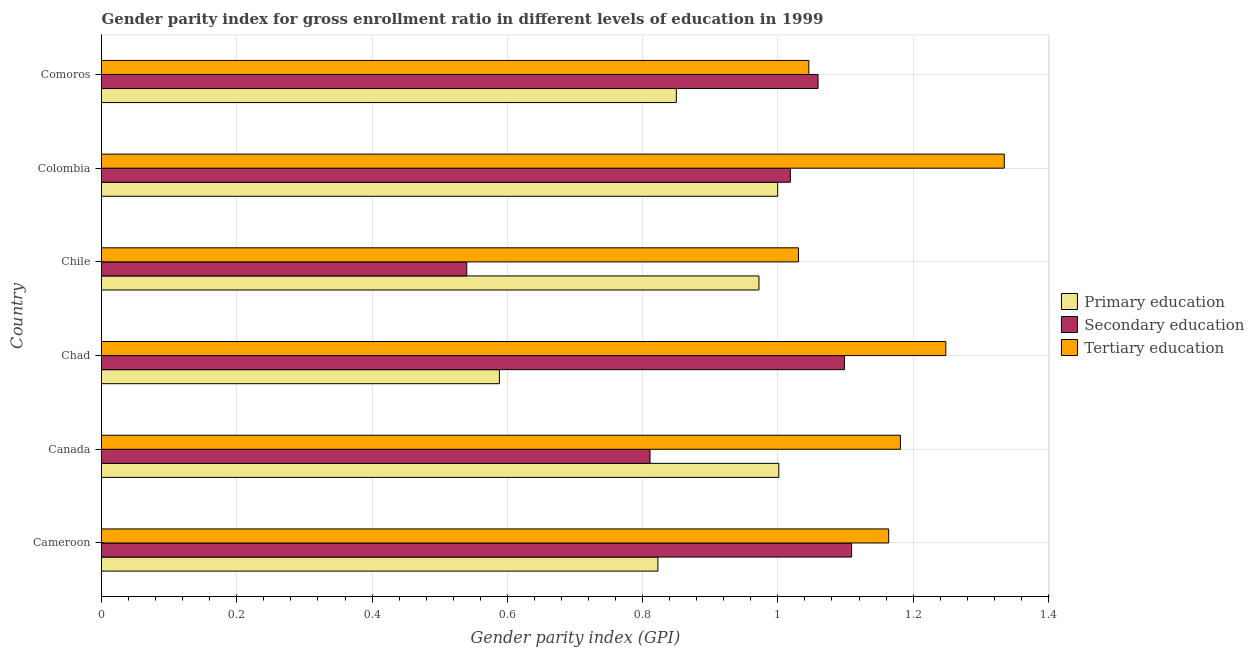How many different coloured bars are there?
Make the answer very short. 3. Are the number of bars per tick equal to the number of legend labels?
Offer a very short reply. Yes. What is the gender parity index in secondary education in Comoros?
Provide a succinct answer. 1.06. Across all countries, what is the maximum gender parity index in secondary education?
Your answer should be very brief. 1.11. Across all countries, what is the minimum gender parity index in tertiary education?
Provide a succinct answer. 1.03. In which country was the gender parity index in primary education minimum?
Your answer should be compact. Chad. What is the total gender parity index in primary education in the graph?
Your response must be concise. 5.23. What is the difference between the gender parity index in secondary education in Cameroon and that in Chile?
Your answer should be very brief. 0.57. What is the difference between the gender parity index in primary education in Colombia and the gender parity index in tertiary education in Chad?
Your answer should be very brief. -0.25. What is the average gender parity index in primary education per country?
Offer a terse response. 0.87. What is the difference between the gender parity index in primary education and gender parity index in tertiary education in Canada?
Offer a very short reply. -0.18. In how many countries, is the gender parity index in tertiary education greater than 0.16 ?
Ensure brevity in your answer.  6. What is the ratio of the gender parity index in secondary education in Cameroon to that in Chad?
Provide a short and direct response. 1.01. Is the difference between the gender parity index in secondary education in Canada and Chile greater than the difference between the gender parity index in primary education in Canada and Chile?
Provide a succinct answer. Yes. What is the difference between the highest and the second highest gender parity index in tertiary education?
Give a very brief answer. 0.09. What is the difference between the highest and the lowest gender parity index in secondary education?
Ensure brevity in your answer.  0.57. Is the sum of the gender parity index in tertiary education in Canada and Chile greater than the maximum gender parity index in secondary education across all countries?
Your answer should be very brief. Yes. What does the 1st bar from the top in Canada represents?
Ensure brevity in your answer.  Tertiary education. Is it the case that in every country, the sum of the gender parity index in primary education and gender parity index in secondary education is greater than the gender parity index in tertiary education?
Make the answer very short. Yes. How many bars are there?
Make the answer very short. 18. Are all the bars in the graph horizontal?
Your answer should be compact. Yes. What is the difference between two consecutive major ticks on the X-axis?
Your response must be concise. 0.2. Does the graph contain any zero values?
Your answer should be compact. No. Does the graph contain grids?
Give a very brief answer. Yes. How are the legend labels stacked?
Make the answer very short. Vertical. What is the title of the graph?
Provide a short and direct response. Gender parity index for gross enrollment ratio in different levels of education in 1999. What is the label or title of the X-axis?
Make the answer very short. Gender parity index (GPI). What is the label or title of the Y-axis?
Provide a succinct answer. Country. What is the Gender parity index (GPI) of Primary education in Cameroon?
Your answer should be compact. 0.82. What is the Gender parity index (GPI) in Secondary education in Cameroon?
Keep it short and to the point. 1.11. What is the Gender parity index (GPI) of Tertiary education in Cameroon?
Provide a succinct answer. 1.16. What is the Gender parity index (GPI) in Primary education in Canada?
Make the answer very short. 1. What is the Gender parity index (GPI) of Secondary education in Canada?
Ensure brevity in your answer.  0.81. What is the Gender parity index (GPI) in Tertiary education in Canada?
Your answer should be compact. 1.18. What is the Gender parity index (GPI) in Primary education in Chad?
Offer a terse response. 0.59. What is the Gender parity index (GPI) in Secondary education in Chad?
Offer a terse response. 1.1. What is the Gender parity index (GPI) of Tertiary education in Chad?
Provide a succinct answer. 1.25. What is the Gender parity index (GPI) in Primary education in Chile?
Your answer should be very brief. 0.97. What is the Gender parity index (GPI) in Secondary education in Chile?
Your answer should be very brief. 0.54. What is the Gender parity index (GPI) of Tertiary education in Chile?
Offer a very short reply. 1.03. What is the Gender parity index (GPI) in Primary education in Colombia?
Make the answer very short. 1. What is the Gender parity index (GPI) in Secondary education in Colombia?
Offer a terse response. 1.02. What is the Gender parity index (GPI) of Tertiary education in Colombia?
Ensure brevity in your answer.  1.33. What is the Gender parity index (GPI) in Primary education in Comoros?
Provide a succinct answer. 0.85. What is the Gender parity index (GPI) of Secondary education in Comoros?
Your answer should be very brief. 1.06. What is the Gender parity index (GPI) of Tertiary education in Comoros?
Provide a short and direct response. 1.05. Across all countries, what is the maximum Gender parity index (GPI) in Primary education?
Your answer should be compact. 1. Across all countries, what is the maximum Gender parity index (GPI) of Secondary education?
Give a very brief answer. 1.11. Across all countries, what is the maximum Gender parity index (GPI) of Tertiary education?
Keep it short and to the point. 1.33. Across all countries, what is the minimum Gender parity index (GPI) in Primary education?
Provide a short and direct response. 0.59. Across all countries, what is the minimum Gender parity index (GPI) of Secondary education?
Your answer should be compact. 0.54. Across all countries, what is the minimum Gender parity index (GPI) in Tertiary education?
Ensure brevity in your answer.  1.03. What is the total Gender parity index (GPI) in Primary education in the graph?
Provide a short and direct response. 5.23. What is the total Gender parity index (GPI) of Secondary education in the graph?
Offer a terse response. 5.64. What is the total Gender parity index (GPI) in Tertiary education in the graph?
Ensure brevity in your answer.  7. What is the difference between the Gender parity index (GPI) in Primary education in Cameroon and that in Canada?
Offer a terse response. -0.18. What is the difference between the Gender parity index (GPI) in Secondary education in Cameroon and that in Canada?
Offer a very short reply. 0.3. What is the difference between the Gender parity index (GPI) in Tertiary education in Cameroon and that in Canada?
Your answer should be compact. -0.02. What is the difference between the Gender parity index (GPI) in Primary education in Cameroon and that in Chad?
Provide a short and direct response. 0.23. What is the difference between the Gender parity index (GPI) of Secondary education in Cameroon and that in Chad?
Make the answer very short. 0.01. What is the difference between the Gender parity index (GPI) of Tertiary education in Cameroon and that in Chad?
Your response must be concise. -0.08. What is the difference between the Gender parity index (GPI) in Primary education in Cameroon and that in Chile?
Your answer should be compact. -0.15. What is the difference between the Gender parity index (GPI) of Secondary education in Cameroon and that in Chile?
Make the answer very short. 0.57. What is the difference between the Gender parity index (GPI) in Tertiary education in Cameroon and that in Chile?
Make the answer very short. 0.13. What is the difference between the Gender parity index (GPI) of Primary education in Cameroon and that in Colombia?
Your answer should be compact. -0.18. What is the difference between the Gender parity index (GPI) in Secondary education in Cameroon and that in Colombia?
Provide a short and direct response. 0.09. What is the difference between the Gender parity index (GPI) in Tertiary education in Cameroon and that in Colombia?
Give a very brief answer. -0.17. What is the difference between the Gender parity index (GPI) of Primary education in Cameroon and that in Comoros?
Your answer should be compact. -0.03. What is the difference between the Gender parity index (GPI) of Secondary education in Cameroon and that in Comoros?
Your answer should be compact. 0.05. What is the difference between the Gender parity index (GPI) of Tertiary education in Cameroon and that in Comoros?
Give a very brief answer. 0.12. What is the difference between the Gender parity index (GPI) of Primary education in Canada and that in Chad?
Offer a very short reply. 0.41. What is the difference between the Gender parity index (GPI) in Secondary education in Canada and that in Chad?
Your response must be concise. -0.29. What is the difference between the Gender parity index (GPI) in Tertiary education in Canada and that in Chad?
Provide a succinct answer. -0.07. What is the difference between the Gender parity index (GPI) in Primary education in Canada and that in Chile?
Your response must be concise. 0.03. What is the difference between the Gender parity index (GPI) in Secondary education in Canada and that in Chile?
Keep it short and to the point. 0.27. What is the difference between the Gender parity index (GPI) of Tertiary education in Canada and that in Chile?
Offer a terse response. 0.15. What is the difference between the Gender parity index (GPI) in Primary education in Canada and that in Colombia?
Make the answer very short. 0. What is the difference between the Gender parity index (GPI) of Secondary education in Canada and that in Colombia?
Give a very brief answer. -0.21. What is the difference between the Gender parity index (GPI) of Tertiary education in Canada and that in Colombia?
Provide a succinct answer. -0.15. What is the difference between the Gender parity index (GPI) in Primary education in Canada and that in Comoros?
Offer a terse response. 0.15. What is the difference between the Gender parity index (GPI) in Secondary education in Canada and that in Comoros?
Give a very brief answer. -0.25. What is the difference between the Gender parity index (GPI) of Tertiary education in Canada and that in Comoros?
Your response must be concise. 0.14. What is the difference between the Gender parity index (GPI) of Primary education in Chad and that in Chile?
Your response must be concise. -0.38. What is the difference between the Gender parity index (GPI) in Secondary education in Chad and that in Chile?
Your answer should be compact. 0.56. What is the difference between the Gender parity index (GPI) of Tertiary education in Chad and that in Chile?
Provide a succinct answer. 0.22. What is the difference between the Gender parity index (GPI) in Primary education in Chad and that in Colombia?
Give a very brief answer. -0.41. What is the difference between the Gender parity index (GPI) in Tertiary education in Chad and that in Colombia?
Offer a very short reply. -0.09. What is the difference between the Gender parity index (GPI) of Primary education in Chad and that in Comoros?
Give a very brief answer. -0.26. What is the difference between the Gender parity index (GPI) in Secondary education in Chad and that in Comoros?
Your response must be concise. 0.04. What is the difference between the Gender parity index (GPI) in Tertiary education in Chad and that in Comoros?
Provide a short and direct response. 0.2. What is the difference between the Gender parity index (GPI) in Primary education in Chile and that in Colombia?
Your response must be concise. -0.03. What is the difference between the Gender parity index (GPI) in Secondary education in Chile and that in Colombia?
Ensure brevity in your answer.  -0.48. What is the difference between the Gender parity index (GPI) in Tertiary education in Chile and that in Colombia?
Make the answer very short. -0.3. What is the difference between the Gender parity index (GPI) of Primary education in Chile and that in Comoros?
Keep it short and to the point. 0.12. What is the difference between the Gender parity index (GPI) of Secondary education in Chile and that in Comoros?
Offer a very short reply. -0.52. What is the difference between the Gender parity index (GPI) of Tertiary education in Chile and that in Comoros?
Offer a terse response. -0.02. What is the difference between the Gender parity index (GPI) of Primary education in Colombia and that in Comoros?
Your answer should be very brief. 0.15. What is the difference between the Gender parity index (GPI) of Secondary education in Colombia and that in Comoros?
Your answer should be very brief. -0.04. What is the difference between the Gender parity index (GPI) in Tertiary education in Colombia and that in Comoros?
Your response must be concise. 0.29. What is the difference between the Gender parity index (GPI) of Primary education in Cameroon and the Gender parity index (GPI) of Secondary education in Canada?
Provide a succinct answer. 0.01. What is the difference between the Gender parity index (GPI) in Primary education in Cameroon and the Gender parity index (GPI) in Tertiary education in Canada?
Offer a very short reply. -0.36. What is the difference between the Gender parity index (GPI) in Secondary education in Cameroon and the Gender parity index (GPI) in Tertiary education in Canada?
Provide a short and direct response. -0.07. What is the difference between the Gender parity index (GPI) of Primary education in Cameroon and the Gender parity index (GPI) of Secondary education in Chad?
Offer a very short reply. -0.28. What is the difference between the Gender parity index (GPI) in Primary education in Cameroon and the Gender parity index (GPI) in Tertiary education in Chad?
Offer a terse response. -0.43. What is the difference between the Gender parity index (GPI) in Secondary education in Cameroon and the Gender parity index (GPI) in Tertiary education in Chad?
Provide a short and direct response. -0.14. What is the difference between the Gender parity index (GPI) of Primary education in Cameroon and the Gender parity index (GPI) of Secondary education in Chile?
Your answer should be compact. 0.28. What is the difference between the Gender parity index (GPI) of Primary education in Cameroon and the Gender parity index (GPI) of Tertiary education in Chile?
Offer a very short reply. -0.21. What is the difference between the Gender parity index (GPI) in Secondary education in Cameroon and the Gender parity index (GPI) in Tertiary education in Chile?
Your answer should be very brief. 0.08. What is the difference between the Gender parity index (GPI) in Primary education in Cameroon and the Gender parity index (GPI) in Secondary education in Colombia?
Provide a short and direct response. -0.2. What is the difference between the Gender parity index (GPI) in Primary education in Cameroon and the Gender parity index (GPI) in Tertiary education in Colombia?
Give a very brief answer. -0.51. What is the difference between the Gender parity index (GPI) in Secondary education in Cameroon and the Gender parity index (GPI) in Tertiary education in Colombia?
Provide a succinct answer. -0.23. What is the difference between the Gender parity index (GPI) of Primary education in Cameroon and the Gender parity index (GPI) of Secondary education in Comoros?
Offer a terse response. -0.24. What is the difference between the Gender parity index (GPI) of Primary education in Cameroon and the Gender parity index (GPI) of Tertiary education in Comoros?
Provide a short and direct response. -0.22. What is the difference between the Gender parity index (GPI) in Secondary education in Cameroon and the Gender parity index (GPI) in Tertiary education in Comoros?
Offer a terse response. 0.06. What is the difference between the Gender parity index (GPI) in Primary education in Canada and the Gender parity index (GPI) in Secondary education in Chad?
Your answer should be very brief. -0.1. What is the difference between the Gender parity index (GPI) in Primary education in Canada and the Gender parity index (GPI) in Tertiary education in Chad?
Provide a succinct answer. -0.25. What is the difference between the Gender parity index (GPI) of Secondary education in Canada and the Gender parity index (GPI) of Tertiary education in Chad?
Your answer should be compact. -0.44. What is the difference between the Gender parity index (GPI) of Primary education in Canada and the Gender parity index (GPI) of Secondary education in Chile?
Provide a short and direct response. 0.46. What is the difference between the Gender parity index (GPI) in Primary education in Canada and the Gender parity index (GPI) in Tertiary education in Chile?
Provide a short and direct response. -0.03. What is the difference between the Gender parity index (GPI) in Secondary education in Canada and the Gender parity index (GPI) in Tertiary education in Chile?
Offer a very short reply. -0.22. What is the difference between the Gender parity index (GPI) of Primary education in Canada and the Gender parity index (GPI) of Secondary education in Colombia?
Make the answer very short. -0.02. What is the difference between the Gender parity index (GPI) in Primary education in Canada and the Gender parity index (GPI) in Tertiary education in Colombia?
Provide a short and direct response. -0.33. What is the difference between the Gender parity index (GPI) of Secondary education in Canada and the Gender parity index (GPI) of Tertiary education in Colombia?
Keep it short and to the point. -0.52. What is the difference between the Gender parity index (GPI) of Primary education in Canada and the Gender parity index (GPI) of Secondary education in Comoros?
Provide a short and direct response. -0.06. What is the difference between the Gender parity index (GPI) of Primary education in Canada and the Gender parity index (GPI) of Tertiary education in Comoros?
Your answer should be very brief. -0.04. What is the difference between the Gender parity index (GPI) of Secondary education in Canada and the Gender parity index (GPI) of Tertiary education in Comoros?
Offer a terse response. -0.23. What is the difference between the Gender parity index (GPI) in Primary education in Chad and the Gender parity index (GPI) in Secondary education in Chile?
Give a very brief answer. 0.05. What is the difference between the Gender parity index (GPI) of Primary education in Chad and the Gender parity index (GPI) of Tertiary education in Chile?
Your answer should be very brief. -0.44. What is the difference between the Gender parity index (GPI) of Secondary education in Chad and the Gender parity index (GPI) of Tertiary education in Chile?
Give a very brief answer. 0.07. What is the difference between the Gender parity index (GPI) of Primary education in Chad and the Gender parity index (GPI) of Secondary education in Colombia?
Your answer should be very brief. -0.43. What is the difference between the Gender parity index (GPI) of Primary education in Chad and the Gender parity index (GPI) of Tertiary education in Colombia?
Offer a terse response. -0.75. What is the difference between the Gender parity index (GPI) in Secondary education in Chad and the Gender parity index (GPI) in Tertiary education in Colombia?
Offer a terse response. -0.24. What is the difference between the Gender parity index (GPI) in Primary education in Chad and the Gender parity index (GPI) in Secondary education in Comoros?
Provide a short and direct response. -0.47. What is the difference between the Gender parity index (GPI) of Primary education in Chad and the Gender parity index (GPI) of Tertiary education in Comoros?
Make the answer very short. -0.46. What is the difference between the Gender parity index (GPI) of Secondary education in Chad and the Gender parity index (GPI) of Tertiary education in Comoros?
Your response must be concise. 0.05. What is the difference between the Gender parity index (GPI) in Primary education in Chile and the Gender parity index (GPI) in Secondary education in Colombia?
Offer a terse response. -0.05. What is the difference between the Gender parity index (GPI) in Primary education in Chile and the Gender parity index (GPI) in Tertiary education in Colombia?
Give a very brief answer. -0.36. What is the difference between the Gender parity index (GPI) in Secondary education in Chile and the Gender parity index (GPI) in Tertiary education in Colombia?
Your answer should be very brief. -0.79. What is the difference between the Gender parity index (GPI) in Primary education in Chile and the Gender parity index (GPI) in Secondary education in Comoros?
Keep it short and to the point. -0.09. What is the difference between the Gender parity index (GPI) of Primary education in Chile and the Gender parity index (GPI) of Tertiary education in Comoros?
Your answer should be very brief. -0.07. What is the difference between the Gender parity index (GPI) in Secondary education in Chile and the Gender parity index (GPI) in Tertiary education in Comoros?
Provide a short and direct response. -0.51. What is the difference between the Gender parity index (GPI) of Primary education in Colombia and the Gender parity index (GPI) of Secondary education in Comoros?
Offer a very short reply. -0.06. What is the difference between the Gender parity index (GPI) in Primary education in Colombia and the Gender parity index (GPI) in Tertiary education in Comoros?
Your response must be concise. -0.05. What is the difference between the Gender parity index (GPI) of Secondary education in Colombia and the Gender parity index (GPI) of Tertiary education in Comoros?
Make the answer very short. -0.03. What is the average Gender parity index (GPI) in Primary education per country?
Your answer should be compact. 0.87. What is the average Gender parity index (GPI) in Secondary education per country?
Give a very brief answer. 0.94. What is the average Gender parity index (GPI) of Tertiary education per country?
Your answer should be very brief. 1.17. What is the difference between the Gender parity index (GPI) in Primary education and Gender parity index (GPI) in Secondary education in Cameroon?
Make the answer very short. -0.29. What is the difference between the Gender parity index (GPI) in Primary education and Gender parity index (GPI) in Tertiary education in Cameroon?
Keep it short and to the point. -0.34. What is the difference between the Gender parity index (GPI) of Secondary education and Gender parity index (GPI) of Tertiary education in Cameroon?
Keep it short and to the point. -0.05. What is the difference between the Gender parity index (GPI) of Primary education and Gender parity index (GPI) of Secondary education in Canada?
Ensure brevity in your answer.  0.19. What is the difference between the Gender parity index (GPI) in Primary education and Gender parity index (GPI) in Tertiary education in Canada?
Provide a succinct answer. -0.18. What is the difference between the Gender parity index (GPI) of Secondary education and Gender parity index (GPI) of Tertiary education in Canada?
Provide a succinct answer. -0.37. What is the difference between the Gender parity index (GPI) in Primary education and Gender parity index (GPI) in Secondary education in Chad?
Your answer should be very brief. -0.51. What is the difference between the Gender parity index (GPI) of Primary education and Gender parity index (GPI) of Tertiary education in Chad?
Provide a succinct answer. -0.66. What is the difference between the Gender parity index (GPI) in Secondary education and Gender parity index (GPI) in Tertiary education in Chad?
Keep it short and to the point. -0.15. What is the difference between the Gender parity index (GPI) in Primary education and Gender parity index (GPI) in Secondary education in Chile?
Make the answer very short. 0.43. What is the difference between the Gender parity index (GPI) of Primary education and Gender parity index (GPI) of Tertiary education in Chile?
Provide a succinct answer. -0.06. What is the difference between the Gender parity index (GPI) of Secondary education and Gender parity index (GPI) of Tertiary education in Chile?
Your response must be concise. -0.49. What is the difference between the Gender parity index (GPI) in Primary education and Gender parity index (GPI) in Secondary education in Colombia?
Keep it short and to the point. -0.02. What is the difference between the Gender parity index (GPI) in Primary education and Gender parity index (GPI) in Tertiary education in Colombia?
Your answer should be very brief. -0.34. What is the difference between the Gender parity index (GPI) in Secondary education and Gender parity index (GPI) in Tertiary education in Colombia?
Offer a very short reply. -0.32. What is the difference between the Gender parity index (GPI) in Primary education and Gender parity index (GPI) in Secondary education in Comoros?
Provide a succinct answer. -0.21. What is the difference between the Gender parity index (GPI) of Primary education and Gender parity index (GPI) of Tertiary education in Comoros?
Ensure brevity in your answer.  -0.2. What is the difference between the Gender parity index (GPI) of Secondary education and Gender parity index (GPI) of Tertiary education in Comoros?
Your response must be concise. 0.01. What is the ratio of the Gender parity index (GPI) of Primary education in Cameroon to that in Canada?
Offer a terse response. 0.82. What is the ratio of the Gender parity index (GPI) in Secondary education in Cameroon to that in Canada?
Your response must be concise. 1.37. What is the ratio of the Gender parity index (GPI) in Tertiary education in Cameroon to that in Canada?
Your response must be concise. 0.99. What is the ratio of the Gender parity index (GPI) of Primary education in Cameroon to that in Chad?
Your response must be concise. 1.4. What is the ratio of the Gender parity index (GPI) of Secondary education in Cameroon to that in Chad?
Keep it short and to the point. 1.01. What is the ratio of the Gender parity index (GPI) of Tertiary education in Cameroon to that in Chad?
Your answer should be very brief. 0.93. What is the ratio of the Gender parity index (GPI) in Primary education in Cameroon to that in Chile?
Offer a terse response. 0.85. What is the ratio of the Gender parity index (GPI) in Secondary education in Cameroon to that in Chile?
Your answer should be compact. 2.05. What is the ratio of the Gender parity index (GPI) of Tertiary education in Cameroon to that in Chile?
Keep it short and to the point. 1.13. What is the ratio of the Gender parity index (GPI) of Primary education in Cameroon to that in Colombia?
Your answer should be compact. 0.82. What is the ratio of the Gender parity index (GPI) in Secondary education in Cameroon to that in Colombia?
Provide a short and direct response. 1.09. What is the ratio of the Gender parity index (GPI) in Tertiary education in Cameroon to that in Colombia?
Offer a very short reply. 0.87. What is the ratio of the Gender parity index (GPI) of Primary education in Cameroon to that in Comoros?
Ensure brevity in your answer.  0.97. What is the ratio of the Gender parity index (GPI) in Secondary education in Cameroon to that in Comoros?
Ensure brevity in your answer.  1.05. What is the ratio of the Gender parity index (GPI) in Tertiary education in Cameroon to that in Comoros?
Offer a very short reply. 1.11. What is the ratio of the Gender parity index (GPI) in Primary education in Canada to that in Chad?
Your answer should be compact. 1.7. What is the ratio of the Gender parity index (GPI) of Secondary education in Canada to that in Chad?
Your response must be concise. 0.74. What is the ratio of the Gender parity index (GPI) of Tertiary education in Canada to that in Chad?
Your answer should be compact. 0.95. What is the ratio of the Gender parity index (GPI) in Primary education in Canada to that in Chile?
Your answer should be very brief. 1.03. What is the ratio of the Gender parity index (GPI) of Secondary education in Canada to that in Chile?
Offer a terse response. 1.5. What is the ratio of the Gender parity index (GPI) in Tertiary education in Canada to that in Chile?
Ensure brevity in your answer.  1.15. What is the ratio of the Gender parity index (GPI) of Primary education in Canada to that in Colombia?
Your answer should be compact. 1. What is the ratio of the Gender parity index (GPI) of Secondary education in Canada to that in Colombia?
Offer a terse response. 0.8. What is the ratio of the Gender parity index (GPI) in Tertiary education in Canada to that in Colombia?
Your answer should be very brief. 0.89. What is the ratio of the Gender parity index (GPI) in Primary education in Canada to that in Comoros?
Offer a terse response. 1.18. What is the ratio of the Gender parity index (GPI) in Secondary education in Canada to that in Comoros?
Make the answer very short. 0.77. What is the ratio of the Gender parity index (GPI) in Tertiary education in Canada to that in Comoros?
Offer a terse response. 1.13. What is the ratio of the Gender parity index (GPI) of Primary education in Chad to that in Chile?
Provide a succinct answer. 0.61. What is the ratio of the Gender parity index (GPI) in Secondary education in Chad to that in Chile?
Provide a succinct answer. 2.03. What is the ratio of the Gender parity index (GPI) in Tertiary education in Chad to that in Chile?
Make the answer very short. 1.21. What is the ratio of the Gender parity index (GPI) of Primary education in Chad to that in Colombia?
Your answer should be very brief. 0.59. What is the ratio of the Gender parity index (GPI) in Secondary education in Chad to that in Colombia?
Keep it short and to the point. 1.08. What is the ratio of the Gender parity index (GPI) in Tertiary education in Chad to that in Colombia?
Offer a terse response. 0.94. What is the ratio of the Gender parity index (GPI) in Primary education in Chad to that in Comoros?
Keep it short and to the point. 0.69. What is the ratio of the Gender parity index (GPI) of Secondary education in Chad to that in Comoros?
Your answer should be very brief. 1.04. What is the ratio of the Gender parity index (GPI) in Tertiary education in Chad to that in Comoros?
Keep it short and to the point. 1.19. What is the ratio of the Gender parity index (GPI) of Primary education in Chile to that in Colombia?
Provide a short and direct response. 0.97. What is the ratio of the Gender parity index (GPI) in Secondary education in Chile to that in Colombia?
Your response must be concise. 0.53. What is the ratio of the Gender parity index (GPI) in Tertiary education in Chile to that in Colombia?
Your answer should be compact. 0.77. What is the ratio of the Gender parity index (GPI) of Primary education in Chile to that in Comoros?
Offer a very short reply. 1.14. What is the ratio of the Gender parity index (GPI) of Secondary education in Chile to that in Comoros?
Offer a very short reply. 0.51. What is the ratio of the Gender parity index (GPI) of Tertiary education in Chile to that in Comoros?
Keep it short and to the point. 0.99. What is the ratio of the Gender parity index (GPI) in Primary education in Colombia to that in Comoros?
Provide a short and direct response. 1.18. What is the ratio of the Gender parity index (GPI) in Secondary education in Colombia to that in Comoros?
Ensure brevity in your answer.  0.96. What is the ratio of the Gender parity index (GPI) in Tertiary education in Colombia to that in Comoros?
Provide a short and direct response. 1.28. What is the difference between the highest and the second highest Gender parity index (GPI) of Primary education?
Keep it short and to the point. 0. What is the difference between the highest and the second highest Gender parity index (GPI) of Secondary education?
Give a very brief answer. 0.01. What is the difference between the highest and the second highest Gender parity index (GPI) in Tertiary education?
Ensure brevity in your answer.  0.09. What is the difference between the highest and the lowest Gender parity index (GPI) of Primary education?
Give a very brief answer. 0.41. What is the difference between the highest and the lowest Gender parity index (GPI) in Secondary education?
Keep it short and to the point. 0.57. What is the difference between the highest and the lowest Gender parity index (GPI) in Tertiary education?
Ensure brevity in your answer.  0.3. 